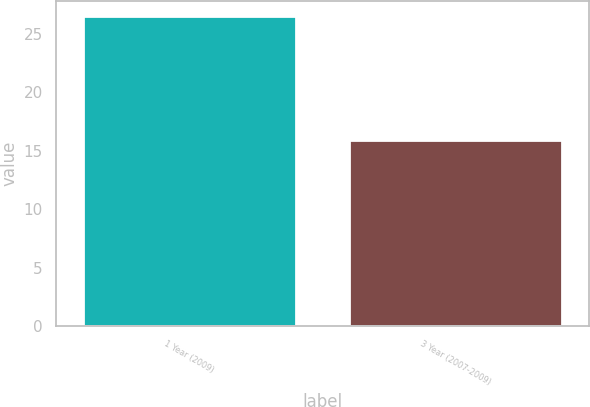Convert chart. <chart><loc_0><loc_0><loc_500><loc_500><bar_chart><fcel>1 Year (2009)<fcel>3 Year (2007-2009)<nl><fcel>26.5<fcel>15.9<nl></chart> 